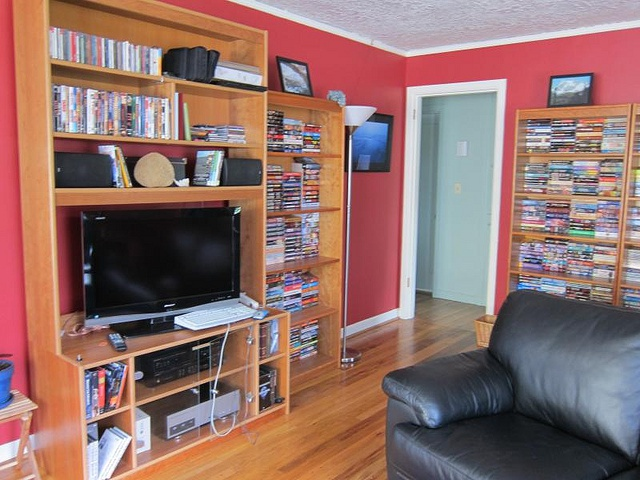Describe the objects in this image and their specific colors. I can see couch in salmon, black, and gray tones, book in salmon, darkgray, gray, brown, and lavender tones, tv in salmon, black, darkgray, gray, and maroon tones, keyboard in salmon, lightblue, and darkgray tones, and potted plant in salmon and blue tones in this image. 